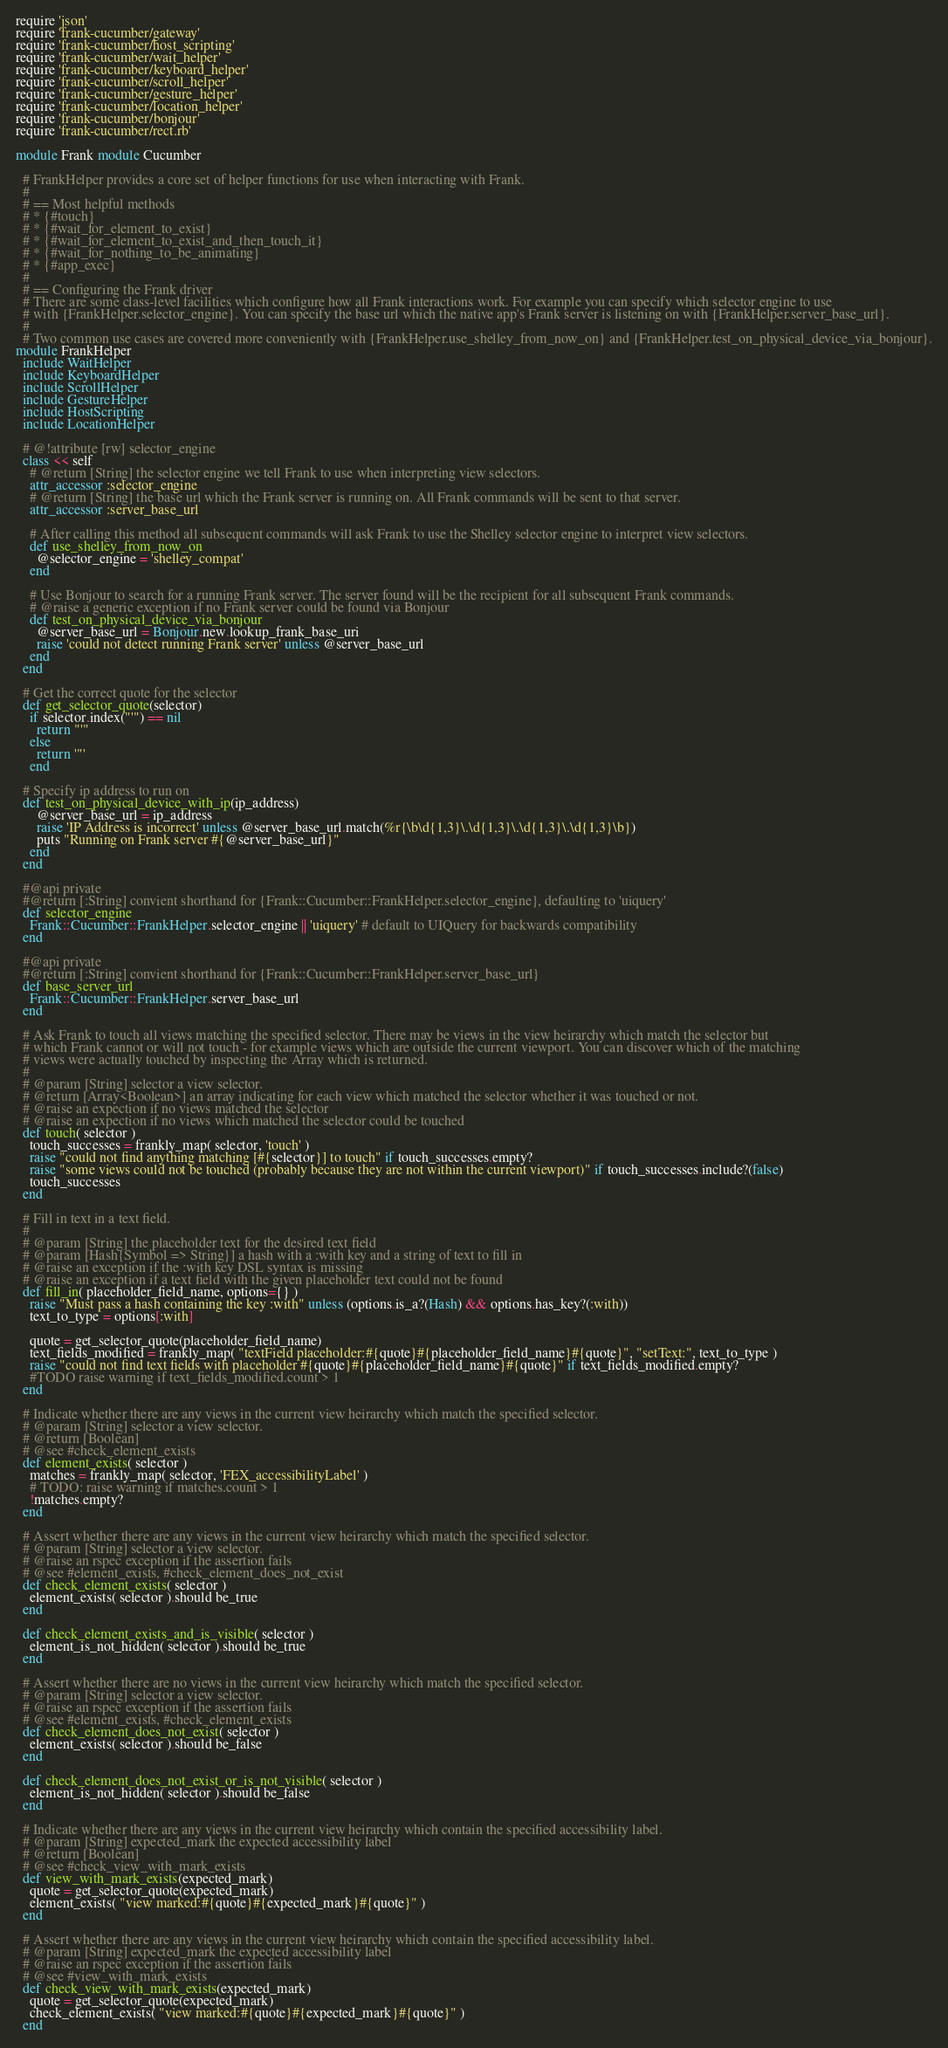Convert code to text. <code><loc_0><loc_0><loc_500><loc_500><_Ruby_>require 'json'
require 'frank-cucumber/gateway'
require 'frank-cucumber/host_scripting'
require 'frank-cucumber/wait_helper'
require 'frank-cucumber/keyboard_helper'
require 'frank-cucumber/scroll_helper'
require 'frank-cucumber/gesture_helper'
require 'frank-cucumber/location_helper'
require 'frank-cucumber/bonjour'
require 'frank-cucumber/rect.rb'

module Frank module Cucumber

  # FrankHelper provides a core set of helper functions for use when interacting with Frank.
  #
  # == Most helpful methods
  # * {#touch}
  # * {#wait_for_element_to_exist}
  # * {#wait_for_element_to_exist_and_then_touch_it}
  # * {#wait_for_nothing_to_be_animating}
  # * {#app_exec}
  #
  # == Configuring the Frank driver
  # There are some class-level facilities which configure how all Frank interactions work. For example you can specify which selector engine to use
  # with {FrankHelper.selector_engine}. You can specify the base url which the native app's Frank server is listening on with {FrankHelper.server_base_url}.
  #
  # Two common use cases are covered more conveniently with {FrankHelper.use_shelley_from_now_on} and {FrankHelper.test_on_physical_device_via_bonjour}.
module FrankHelper
  include WaitHelper
  include KeyboardHelper
  include ScrollHelper
  include GestureHelper
  include HostScripting
  include LocationHelper

  # @!attribute [rw] selector_engine
  class << self
    # @return [String] the selector engine we tell Frank to use when interpreting view selectors.
    attr_accessor :selector_engine
    # @return [String] the base url which the Frank server is running on. All Frank commands will be sent to that server.
    attr_accessor :server_base_url

    # After calling this method all subsequent commands will ask Frank to use the Shelley selector engine to interpret view selectors.
    def use_shelley_from_now_on
      @selector_engine = 'shelley_compat'
    end

    # Use Bonjour to search for a running Frank server. The server found will be the recipient for all subsequent Frank commands.
    # @raise a generic exception if no Frank server could be found via Bonjour
    def test_on_physical_device_via_bonjour
      @server_base_url = Bonjour.new.lookup_frank_base_uri
      raise 'could not detect running Frank server' unless @server_base_url
    end
  end

  # Get the correct quote for the selector
  def get_selector_quote(selector)
    if selector.index("'") == nil
      return "'"
    else
      return '"'
    end

  # Specify ip address to run on
  def test_on_physical_device_with_ip(ip_address)
      @server_base_url = ip_address
      raise 'IP Address is incorrect' unless @server_base_url.match(%r{\b\d{1,3}\.\d{1,3}\.\d{1,3}\.\d{1,3}\b})
      puts "Running on Frank server #{@server_base_url}"
    end
  end

  #@api private
  #@return [:String] convient shorthand for {Frank::Cucumber::FrankHelper.selector_engine}, defaulting to 'uiquery'
  def selector_engine
    Frank::Cucumber::FrankHelper.selector_engine || 'uiquery' # default to UIQuery for backwards compatibility
  end

  #@api private
  #@return [:String] convient shorthand for {Frank::Cucumber::FrankHelper.server_base_url}
  def base_server_url
    Frank::Cucumber::FrankHelper.server_base_url
  end

  # Ask Frank to touch all views matching the specified selector. There may be views in the view heirarchy which match the selector but
  # which Frank cannot or will not touch - for example views which are outside the current viewport. You can discover which of the matching
  # views were actually touched by inspecting the Array which is returned.
  #
  # @param [String] selector a view selector.
  # @return [Array<Boolean>] an array indicating for each view which matched the selector whether it was touched or not.
  # @raise an expection if no views matched the selector
  # @raise an expection if no views which matched the selector could be touched
  def touch( selector )
    touch_successes = frankly_map( selector, 'touch' )
    raise "could not find anything matching [#{selector}] to touch" if touch_successes.empty?
    raise "some views could not be touched (probably because they are not within the current viewport)" if touch_successes.include?(false)
    touch_successes
  end

  # Fill in text in a text field.
  #
  # @param [String] the placeholder text for the desired text field
  # @param [Hash{Symbol => String}] a hash with a :with key and a string of text to fill in
  # @raise an exception if the :with key DSL syntax is missing
  # @raise an exception if a text field with the given placeholder text could not be found
  def fill_in( placeholder_field_name, options={} )
    raise "Must pass a hash containing the key :with" unless (options.is_a?(Hash) && options.has_key?(:with))
    text_to_type = options[:with]

    quote = get_selector_quote(placeholder_field_name)
    text_fields_modified = frankly_map( "textField placeholder:#{quote}#{placeholder_field_name}#{quote}", "setText:", text_to_type )
    raise "could not find text fields with placeholder #{quote}#{placeholder_field_name}#{quote}" if text_fields_modified.empty?
    #TODO raise warning if text_fields_modified.count > 1
  end

  # Indicate whether there are any views in the current view heirarchy which match the specified selector.
  # @param [String] selector a view selector.
  # @return [Boolean]
  # @see #check_element_exists
  def element_exists( selector )
    matches = frankly_map( selector, 'FEX_accessibilityLabel' )
    # TODO: raise warning if matches.count > 1
    !matches.empty?
  end

  # Assert whether there are any views in the current view heirarchy which match the specified selector.
  # @param [String] selector a view selector.
  # @raise an rspec exception if the assertion fails
  # @see #element_exists, #check_element_does_not_exist
  def check_element_exists( selector )
    element_exists( selector ).should be_true
  end

  def check_element_exists_and_is_visible( selector )
    element_is_not_hidden( selector ).should be_true
  end

  # Assert whether there are no views in the current view heirarchy which match the specified selector.
  # @param [String] selector a view selector.
  # @raise an rspec exception if the assertion fails
  # @see #element_exists, #check_element_exists
  def check_element_does_not_exist( selector )
    element_exists( selector ).should be_false
  end

  def check_element_does_not_exist_or_is_not_visible( selector )
    element_is_not_hidden( selector ).should be_false
  end

  # Indicate whether there are any views in the current view heirarchy which contain the specified accessibility label.
  # @param [String] expected_mark the expected accessibility label
  # @return [Boolean]
  # @see #check_view_with_mark_exists
  def view_with_mark_exists(expected_mark)
    quote = get_selector_quote(expected_mark)
    element_exists( "view marked:#{quote}#{expected_mark}#{quote}" )
  end

  # Assert whether there are any views in the current view heirarchy which contain the specified accessibility label.
  # @param [String] expected_mark the expected accessibility label
  # @raise an rspec exception if the assertion fails
  # @see #view_with_mark_exists
  def check_view_with_mark_exists(expected_mark)
    quote = get_selector_quote(expected_mark)
    check_element_exists( "view marked:#{quote}#{expected_mark}#{quote}" )
  end
</code> 